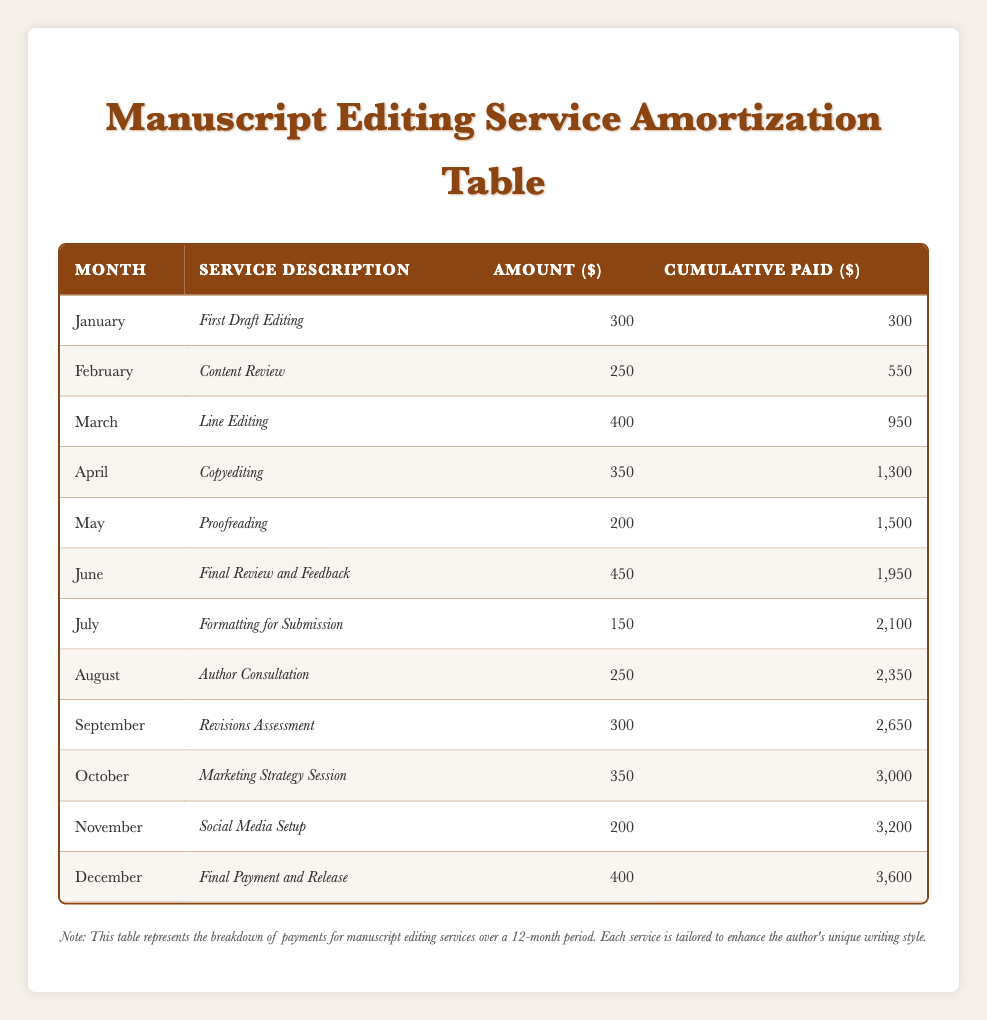What service was paid for in March? According to the table, March includes the service description "Line Editing," which corresponds to the payment made that month.
Answer: Line Editing How much was paid in June? The amount paid in June is listed in the table as 450, representing the price for "Final Review and Feedback."
Answer: 450 What is the total amount paid from January to May? Starting from January to May, the payments are: 300 + 250 + 400 + 350 + 200 = 1500. Therefore, the total is 1500.
Answer: 1500 Did the payment for "Formatting for Submission" in July exceed 200? The payment for "Formatting for Submission" in July is listed as 150, which is less than 200.
Answer: No Which month had the highest individual payment and what was the amount? Examining the amounts, June's payment of 450 is the highest listed in the table, making it the month with the highest individual payment.
Answer: June, 450 What was the cumulative amount paid by September? The cumulative amount paid by September can be found in the table, which lists it as 2650. This value is the total cumulative payment up to that month.
Answer: 2650 Was the cumulative total at the end of the year above 3000? The cumulative amount at the end of December is stated as 3600, which is indeed above 3000.
Answer: Yes How many services were provided by October? To determine the number of services, count all entries from January to October, which totals 10 services listed in the table.
Answer: 10 What is the average monthly payment from January to December? The total amount paid over the year is 3600. Since there are 12 months, the average monthly payment is 3600 divided by 12, which equates to 300.
Answer: 300 